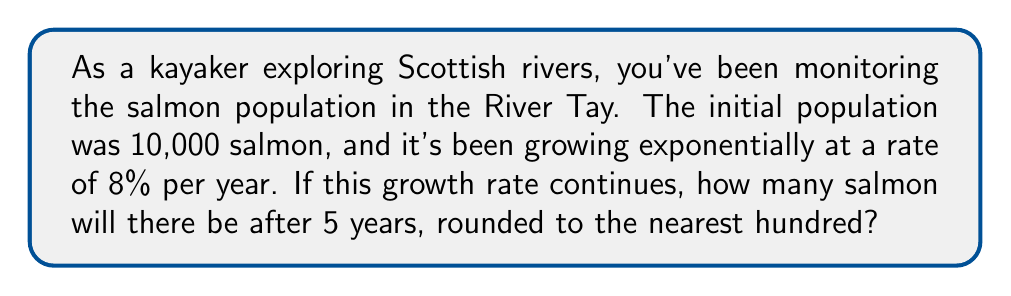What is the answer to this math problem? Let's approach this step-by-step using the exponential growth model:

1) The exponential growth formula is:
   $$A = P(1 + r)^t$$
   Where:
   $A$ = final amount
   $P$ = initial principal (starting amount)
   $r$ = growth rate (as a decimal)
   $t$ = time period

2) We have:
   $P = 10,000$ (initial population)
   $r = 0.08$ (8% growth rate as a decimal)
   $t = 5$ years

3) Let's plug these values into our formula:
   $$A = 10,000(1 + 0.08)^5$$

4) Simplify inside the parentheses:
   $$A = 10,000(1.08)^5$$

5) Calculate the exponent:
   $$A = 10,000 * 1.46933...$$

6) Multiply:
   $$A = 14,693.28...$$

7) Rounding to the nearest hundred:
   $$A ≈ 14,700$$
Answer: 14,700 salmon 